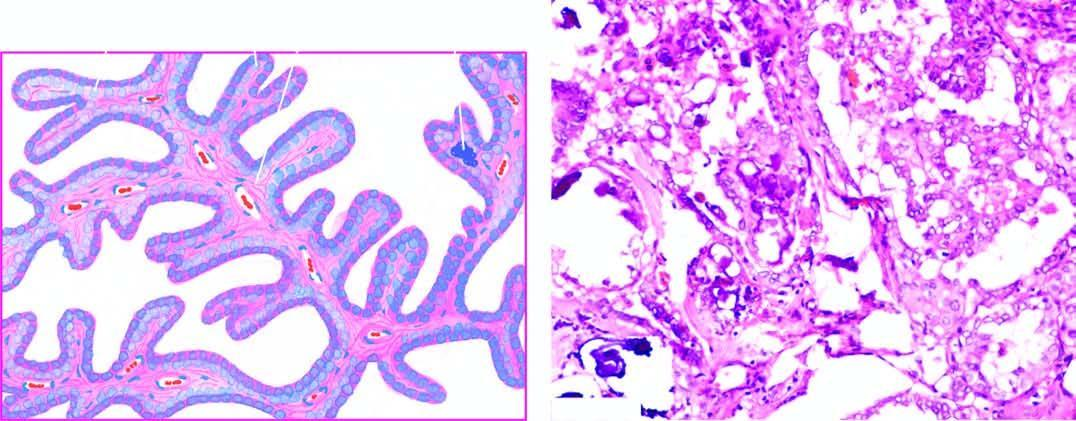does microscopy show branching papillae having flbrovascular stalk covered by a single layer of cuboidal cells having ground-glass nuclei?
Answer the question using a single word or phrase. Yes 